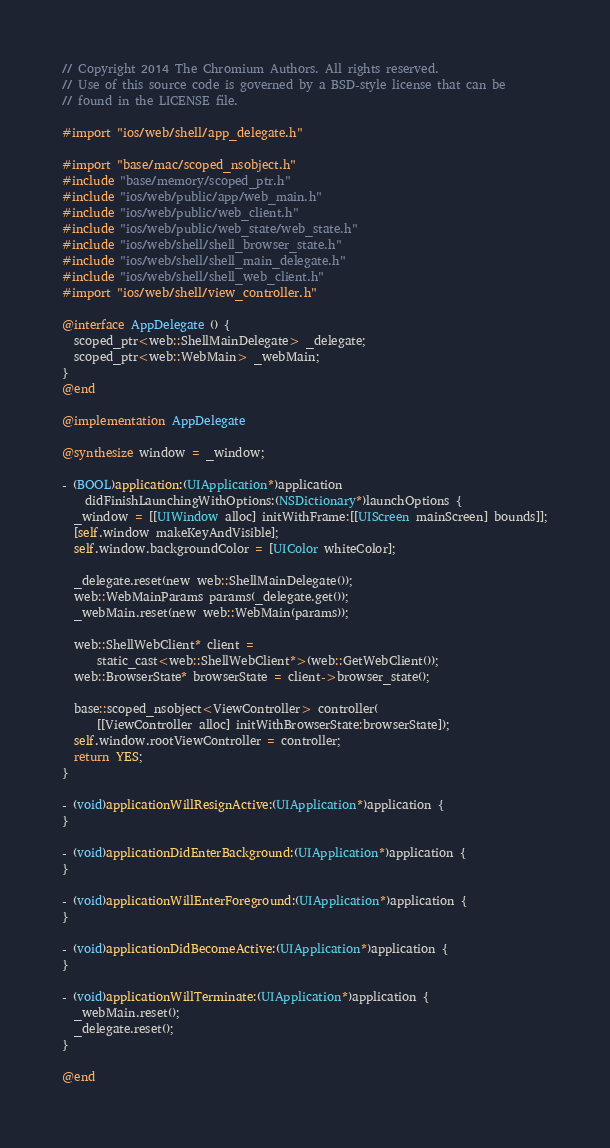Convert code to text. <code><loc_0><loc_0><loc_500><loc_500><_ObjectiveC_>// Copyright 2014 The Chromium Authors. All rights reserved.
// Use of this source code is governed by a BSD-style license that can be
// found in the LICENSE file.

#import "ios/web/shell/app_delegate.h"

#import "base/mac/scoped_nsobject.h"
#include "base/memory/scoped_ptr.h"
#include "ios/web/public/app/web_main.h"
#include "ios/web/public/web_client.h"
#include "ios/web/public/web_state/web_state.h"
#include "ios/web/shell/shell_browser_state.h"
#include "ios/web/shell/shell_main_delegate.h"
#include "ios/web/shell/shell_web_client.h"
#import "ios/web/shell/view_controller.h"

@interface AppDelegate () {
  scoped_ptr<web::ShellMainDelegate> _delegate;
  scoped_ptr<web::WebMain> _webMain;
}
@end

@implementation AppDelegate

@synthesize window = _window;

- (BOOL)application:(UIApplication*)application
    didFinishLaunchingWithOptions:(NSDictionary*)launchOptions {
  _window = [[UIWindow alloc] initWithFrame:[[UIScreen mainScreen] bounds]];
  [self.window makeKeyAndVisible];
  self.window.backgroundColor = [UIColor whiteColor];

  _delegate.reset(new web::ShellMainDelegate());
  web::WebMainParams params(_delegate.get());
  _webMain.reset(new web::WebMain(params));

  web::ShellWebClient* client =
      static_cast<web::ShellWebClient*>(web::GetWebClient());
  web::BrowserState* browserState = client->browser_state();

  base::scoped_nsobject<ViewController> controller(
      [[ViewController alloc] initWithBrowserState:browserState]);
  self.window.rootViewController = controller;
  return YES;
}

- (void)applicationWillResignActive:(UIApplication*)application {
}

- (void)applicationDidEnterBackground:(UIApplication*)application {
}

- (void)applicationWillEnterForeground:(UIApplication*)application {
}

- (void)applicationDidBecomeActive:(UIApplication*)application {
}

- (void)applicationWillTerminate:(UIApplication*)application {
  _webMain.reset();
  _delegate.reset();
}

@end
</code> 